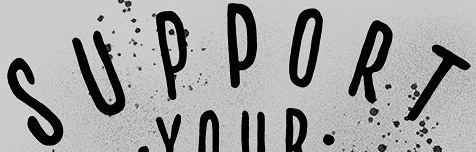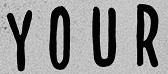Transcribe the words shown in these images in order, separated by a semicolon. SUPPORT; YOUR 